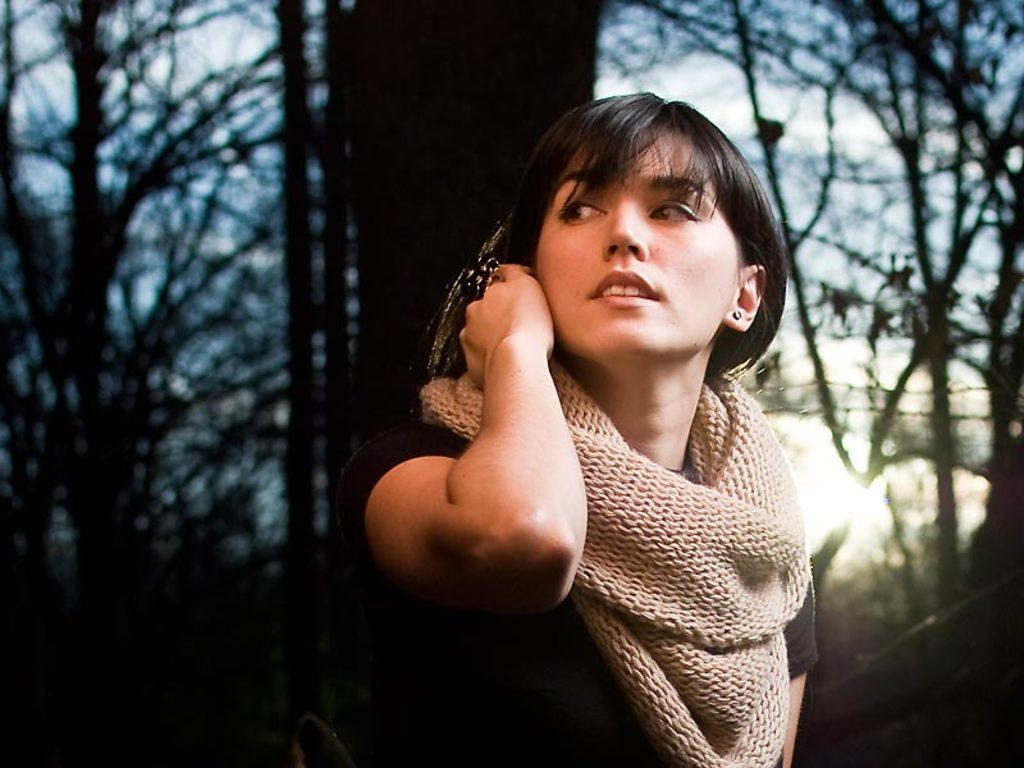Who is present in the image? There is a woman in the image. What is the woman wearing in the image? The woman is wearing a scarf in the image. What is the woman's facial expression in the image? The woman is smiling in the image. What is the woman doing in the image? The woman is watching something in the image. What can be seen in the background of the image? There are trees, light, and clouds in the sky in the background of the image. How many planes can be seen flying through the hole in the image? There is no hole or planes present in the image. 